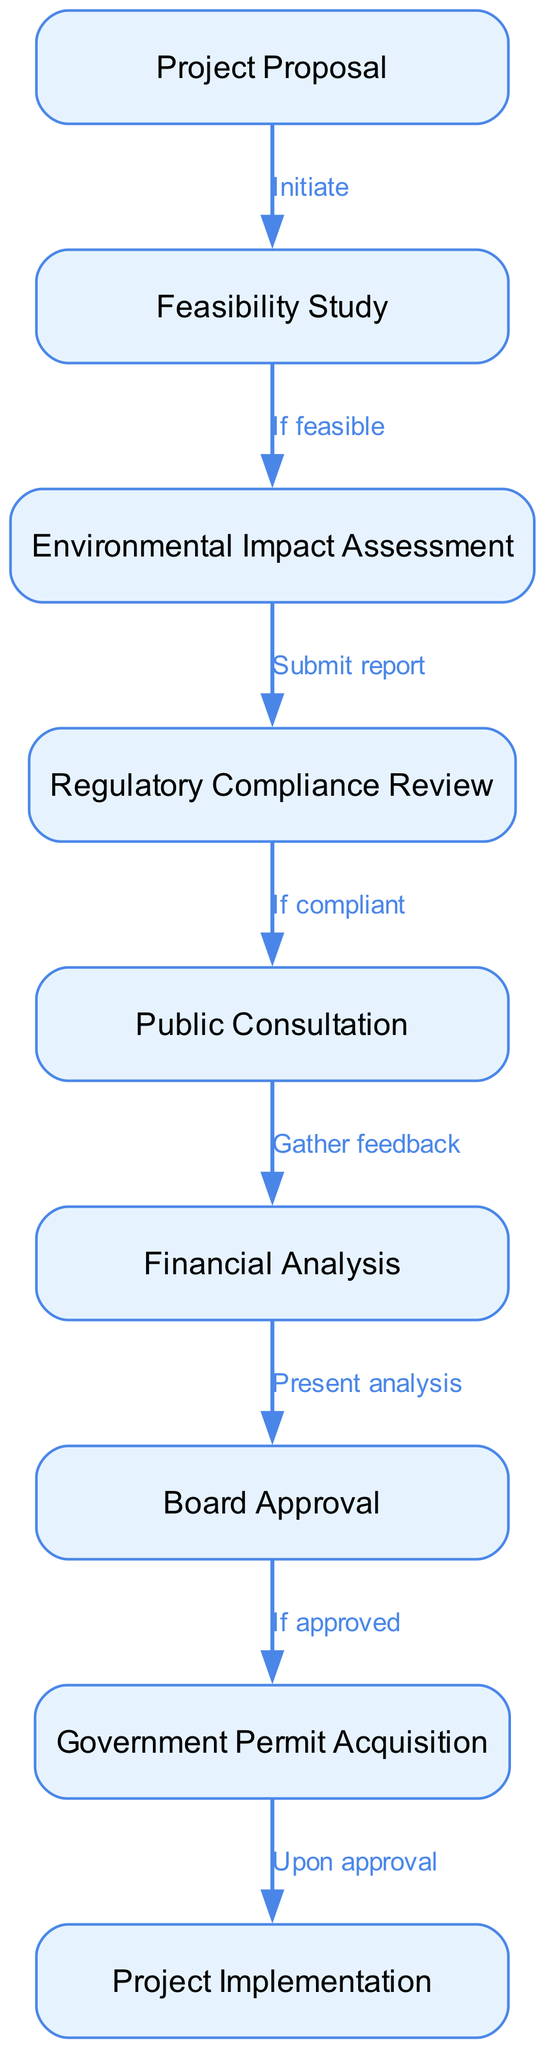What is the first step in the project approval process? The flow chart begins with the "Project Proposal," which is identified as the first node in the diagram.
Answer: Project Proposal How many nodes are present in the diagram? By counting the listed nodes in the diagram, we find there are nine distinct steps represented.
Answer: Nine What is the label of the node that follows the Environmental Impact Assessment? The Environmental Impact Assessment node leads to the Regulatory Compliance Review, which is the subsequent step in the process, as represented by the directed edge in the diagram.
Answer: Regulatory Compliance Review What action follows the Board Approval step? The diagram indicates that after the Board Approval stage is completed, the next step is the Government Permit Acquisition, which is directly connected by the labeled edge.
Answer: Government Permit Acquisition Which step requires a financial analysis? The financial analysis is specifically indicated after the Public Consultation step, as shown in the flow chart connecting those two nodes.
Answer: Financial Analysis What two conditions must be met to proceed from the Regulatory Compliance Review? From the flow chart, the condition specified is "If compliant," which implies that regulatory compliance must be met to continue to the next step, Public Consultation.
Answer: If compliant Identify the step where public feedback is gathered. The Public Consultation node in the flow chart is designated for gathering feedback, indicating the involvement of stakeholders.
Answer: Public Consultation What is the final stage before project implementation? According to the flow chart, the final prerequisite before moving to Project Implementation is the Government Permit Acquisition, which is indicated in the sequence of nodes.
Answer: Government Permit Acquisition What must happen after the Financial Analysis is presented? The flow chart shows that the next action after presenting the financial analysis is to seek Board Approval, as denoted by the directional flow.
Answer: Board Approval 